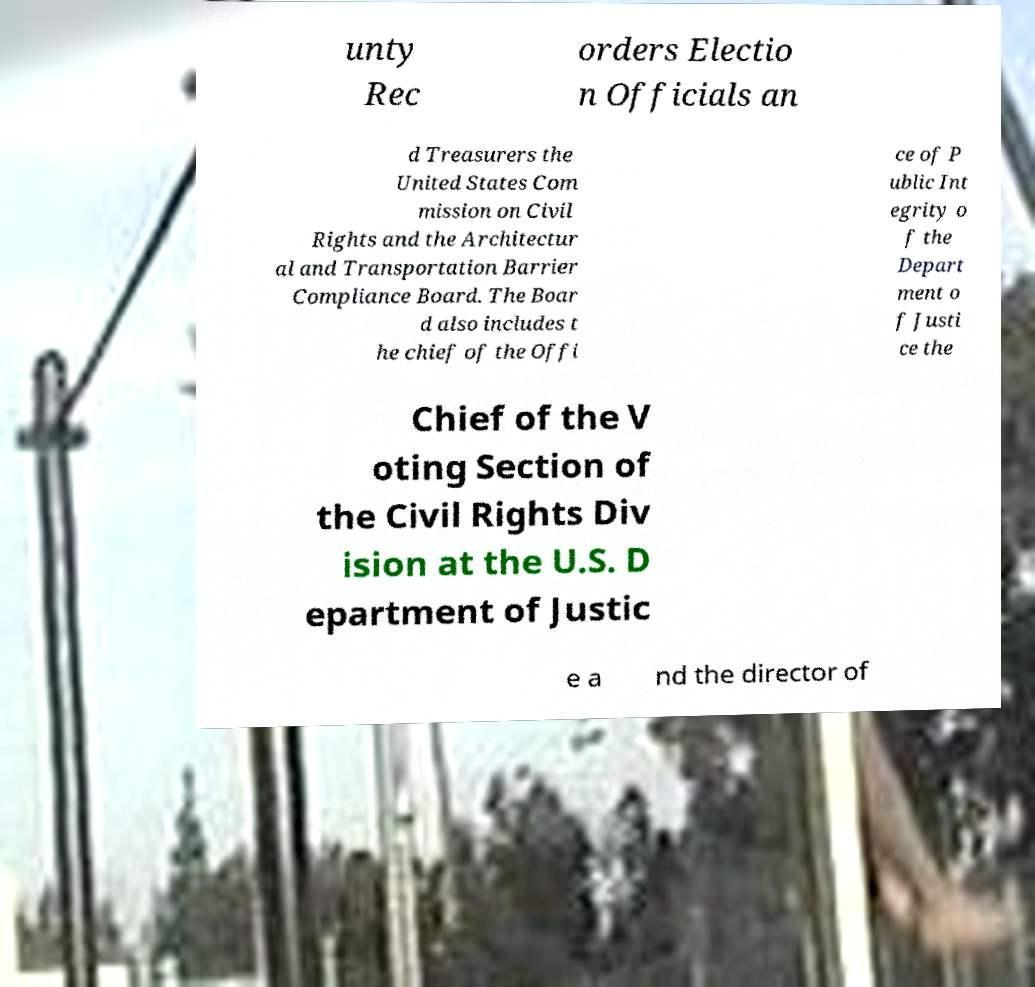Can you accurately transcribe the text from the provided image for me? unty Rec orders Electio n Officials an d Treasurers the United States Com mission on Civil Rights and the Architectur al and Transportation Barrier Compliance Board. The Boar d also includes t he chief of the Offi ce of P ublic Int egrity o f the Depart ment o f Justi ce the Chief of the V oting Section of the Civil Rights Div ision at the U.S. D epartment of Justic e a nd the director of 